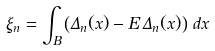Convert formula to latex. <formula><loc_0><loc_0><loc_500><loc_500>\xi _ { n } = \int _ { B } \left ( \Delta _ { n } ( x ) - { E } \, \Delta _ { n } ( x ) \right ) \, d x</formula> 